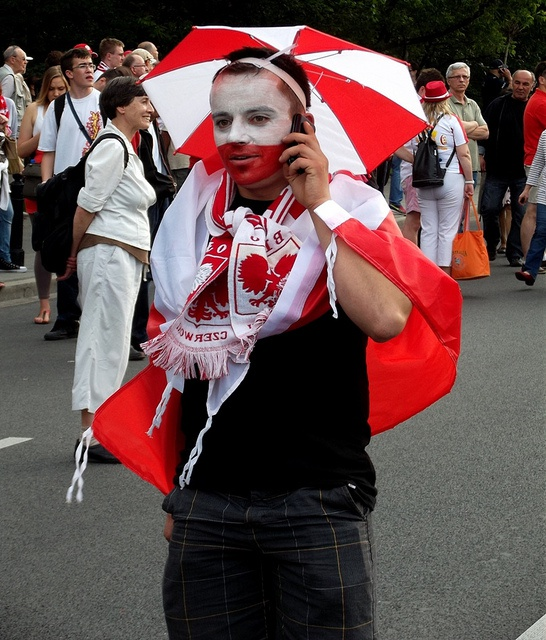Describe the objects in this image and their specific colors. I can see people in black, red, lavender, and darkgray tones, people in black, darkgray, and lightgray tones, umbrella in black, white, red, and brown tones, people in black, darkgray, lavender, and gray tones, and people in black, maroon, brown, and gray tones in this image. 